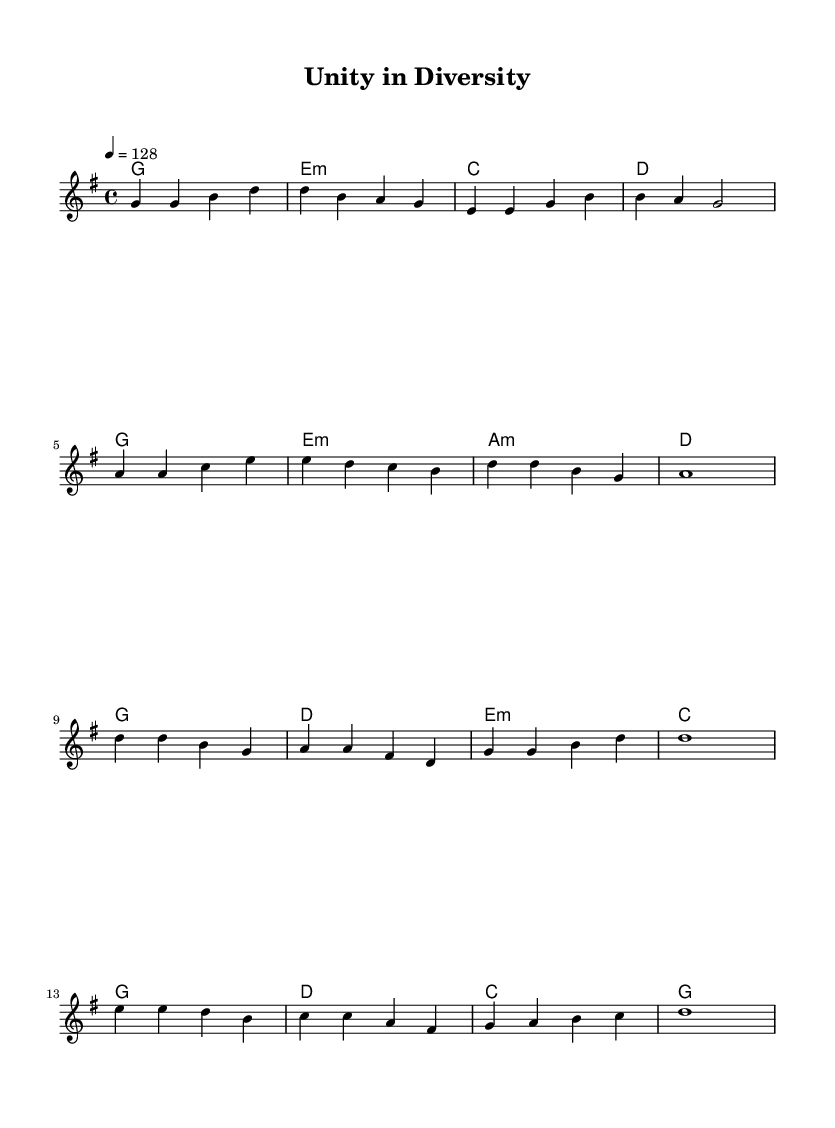What is the key signature of this music? The key signature is G major, which has one sharp (F#) indicated in the beginning of the staff.
Answer: G major What is the time signature of this piece? The time signature is 4/4, as shown at the beginning of the staff, indicating four beats per measure and a quarter note receives one beat.
Answer: 4/4 What is the tempo marking of the piece? The tempo is marked as 128 beats per minute, which can be found next to the time signature at the start of the score.
Answer: 128 How many measures are in the verse section? The verse section consists of eight measures, counted from the beginning of the melody to the end of the indicated notes.
Answer: Eight What type of chords are indicated during the verse? The chords during the verse include major and minor chords, as evidenced by the chord names shown above the melody.
Answer: Major and minor What is the highest note in the melody? The highest note in the melody is D, which can be identified by examining the notes in the melody line throughout the piece.
Answer: D What is the lyrical theme suggested by the title "Unity in Diversity"? The title suggests themes of multicultural celebration and collaboration, reflected in the energetic style common to K-Pop music.
Answer: Multicultural celebration 